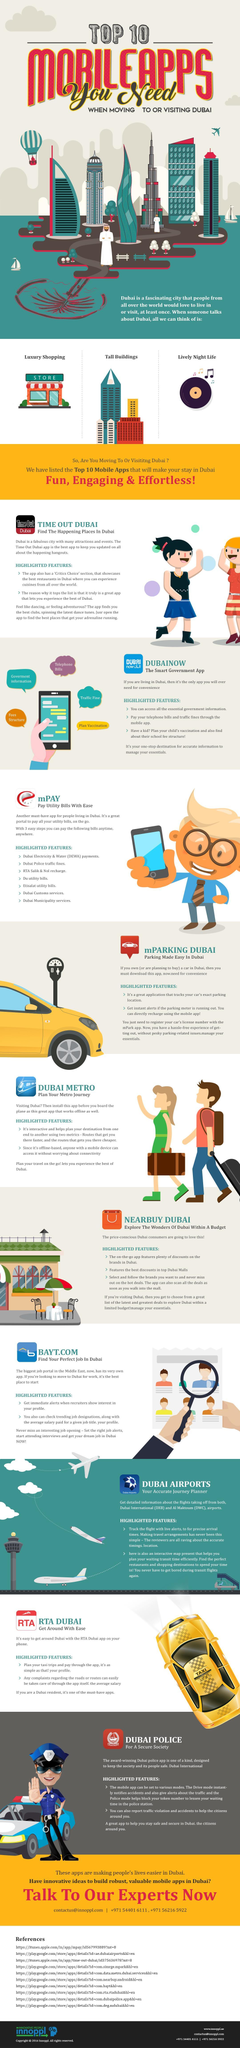Which mobile app gives information about best restaurants or clubs in the city?
Answer the question with a short phrase. Time Out Dubai Which app gives information on discounts at top malls in Dubai? NEARBUY DUBAI Which app helps in making best use of transit time between flights? Dubai Airports Which app helps you stay safe and secure in Dubai? DUBAI POLICE Which app helps track parking location of your vehicle? mPARKING DUBAI Which app helps to find faster and cheaper routes in Dubai? DUBAI METRO Which app helps find information about school fees or vaccinations? Dubainow Which is the mobile app that helps pay electricity and water bills? mPAY Which app can be used to plan taxi trips? RTA DUBAI Which app would be most helpful if you looking for employment opportunities in Dubai? BAYT.com 